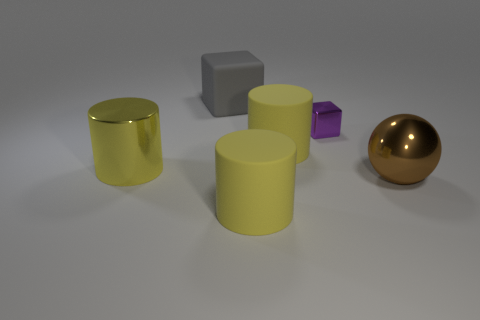Is there any other thing that has the same size as the metallic block?
Keep it short and to the point. No. Is the number of big rubber things less than the number of brown spheres?
Make the answer very short. No. There is a ball that is the same size as the gray rubber cube; what material is it?
Give a very brief answer. Metal. There is a thing that is right of the metal cube; is it the same size as the matte cylinder in front of the big brown shiny sphere?
Give a very brief answer. Yes. Is there another brown sphere made of the same material as the sphere?
Ensure brevity in your answer.  No. What number of things are shiny objects that are on the right side of the metallic block or large blocks?
Your answer should be compact. 2. Is the big yellow object that is in front of the sphere made of the same material as the large sphere?
Make the answer very short. No. Is the shape of the gray thing the same as the tiny object?
Make the answer very short. Yes. There is a big yellow rubber cylinder behind the metallic ball; how many rubber things are left of it?
Provide a short and direct response. 2. There is another thing that is the same shape as the purple object; what is it made of?
Your answer should be compact. Rubber. 